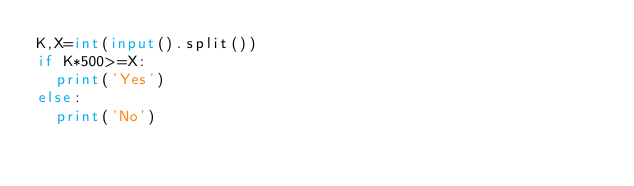<code> <loc_0><loc_0><loc_500><loc_500><_Python_>K,X=int(input().split())
if K*500>=X:
  print('Yes')
else:
  print('No')</code> 